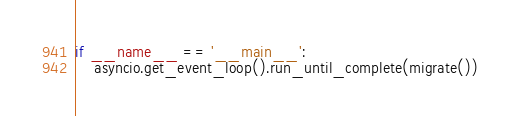<code> <loc_0><loc_0><loc_500><loc_500><_Python_>
if __name__ == '__main__':
    asyncio.get_event_loop().run_until_complete(migrate())
</code> 